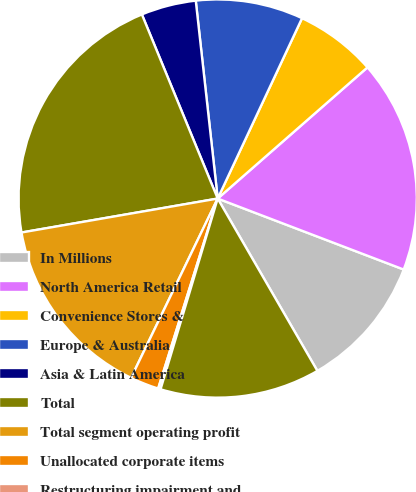Convert chart to OTSL. <chart><loc_0><loc_0><loc_500><loc_500><pie_chart><fcel>In Millions<fcel>North America Retail<fcel>Convenience Stores &<fcel>Europe & Australia<fcel>Asia & Latin America<fcel>Total<fcel>Total segment operating profit<fcel>Unallocated corporate items<fcel>Restructuring impairment and<fcel>Operating profit<nl><fcel>10.85%<fcel>17.25%<fcel>6.59%<fcel>8.72%<fcel>4.46%<fcel>21.51%<fcel>15.11%<fcel>2.33%<fcel>0.2%<fcel>12.98%<nl></chart> 